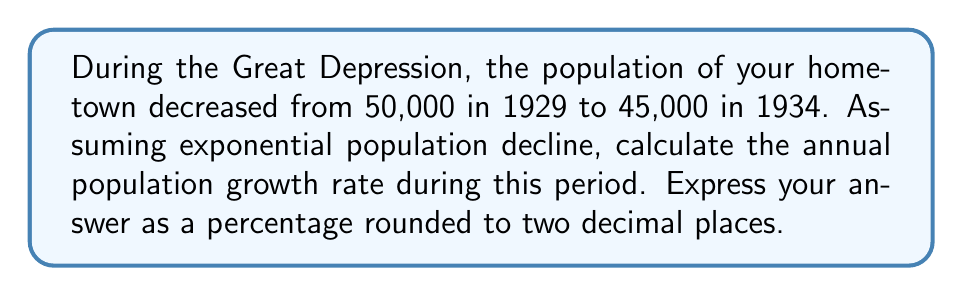Show me your answer to this math problem. Let's approach this step-by-step:

1) The formula for exponential growth (or decline) is:

   $$P(t) = P_0 \cdot e^{rt}$$

   Where:
   $P(t)$ is the population at time $t$
   $P_0$ is the initial population
   $r$ is the growth rate
   $t$ is the time period

2) We know:
   $P_0 = 50,000$ (population in 1929)
   $P(t) = 45,000$ (population in 1934)
   $t = 5$ years

3) Plugging these into our formula:

   $$45,000 = 50,000 \cdot e^{5r}$$

4) Dividing both sides by 50,000:

   $$0.9 = e^{5r}$$

5) Taking the natural log of both sides:

   $$\ln(0.9) = 5r$$

6) Solving for $r$:

   $$r = \frac{\ln(0.9)}{5} \approx -0.02107$$

7) To convert to a percentage, multiply by 100:

   $$-0.02107 \cdot 100 \approx -2.11\%$$

8) Rounding to two decimal places: -2.11%

Note: The negative value indicates population decline.
Answer: -2.11% 